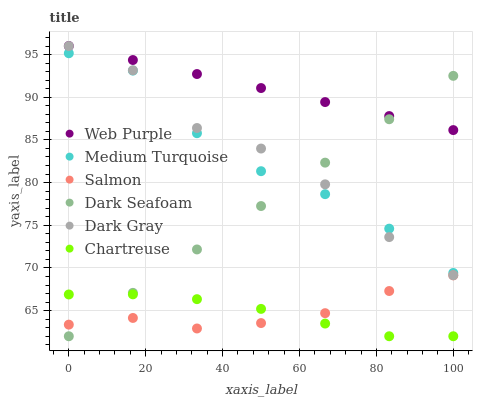Does Chartreuse have the minimum area under the curve?
Answer yes or no. Yes. Does Web Purple have the maximum area under the curve?
Answer yes or no. Yes. Does Dark Seafoam have the minimum area under the curve?
Answer yes or no. No. Does Dark Seafoam have the maximum area under the curve?
Answer yes or no. No. Is Web Purple the smoothest?
Answer yes or no. Yes. Is Dark Gray the roughest?
Answer yes or no. Yes. Is Dark Seafoam the smoothest?
Answer yes or no. No. Is Dark Seafoam the roughest?
Answer yes or no. No. Does Dark Seafoam have the lowest value?
Answer yes or no. Yes. Does Web Purple have the lowest value?
Answer yes or no. No. Does Dark Gray have the highest value?
Answer yes or no. Yes. Does Dark Seafoam have the highest value?
Answer yes or no. No. Is Salmon less than Medium Turquoise?
Answer yes or no. Yes. Is Web Purple greater than Chartreuse?
Answer yes or no. Yes. Does Medium Turquoise intersect Dark Seafoam?
Answer yes or no. Yes. Is Medium Turquoise less than Dark Seafoam?
Answer yes or no. No. Is Medium Turquoise greater than Dark Seafoam?
Answer yes or no. No. Does Salmon intersect Medium Turquoise?
Answer yes or no. No. 